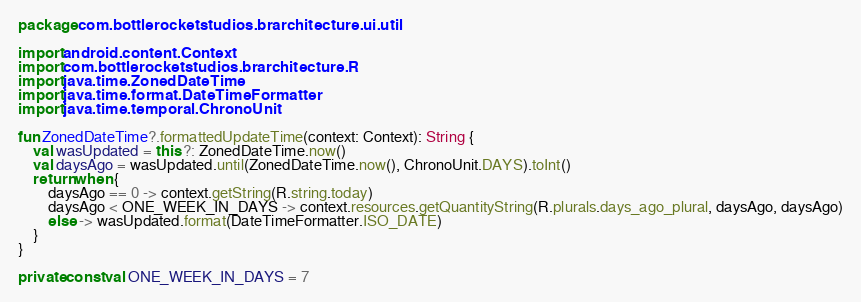<code> <loc_0><loc_0><loc_500><loc_500><_Kotlin_>package com.bottlerocketstudios.brarchitecture.ui.util

import android.content.Context
import com.bottlerocketstudios.brarchitecture.R
import java.time.ZonedDateTime
import java.time.format.DateTimeFormatter
import java.time.temporal.ChronoUnit

fun ZonedDateTime?.formattedUpdateTime(context: Context): String {
    val wasUpdated = this ?: ZonedDateTime.now()
    val daysAgo = wasUpdated.until(ZonedDateTime.now(), ChronoUnit.DAYS).toInt()
    return when {
        daysAgo == 0 -> context.getString(R.string.today)
        daysAgo < ONE_WEEK_IN_DAYS -> context.resources.getQuantityString(R.plurals.days_ago_plural, daysAgo, daysAgo)
        else -> wasUpdated.format(DateTimeFormatter.ISO_DATE)
    }
}

private const val ONE_WEEK_IN_DAYS = 7
</code> 